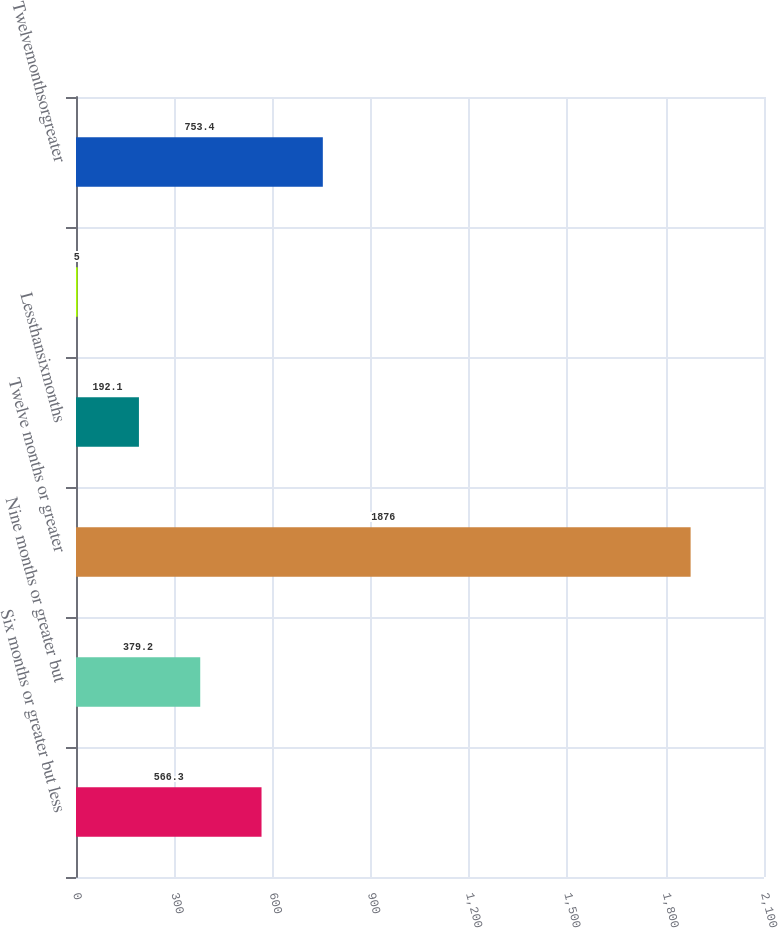<chart> <loc_0><loc_0><loc_500><loc_500><bar_chart><fcel>Six months or greater but less<fcel>Nine months or greater but<fcel>Twelve months or greater<fcel>Lessthansixmonths<fcel>Unnamed: 4<fcel>Twelvemonthsorgreater<nl><fcel>566.3<fcel>379.2<fcel>1876<fcel>192.1<fcel>5<fcel>753.4<nl></chart> 